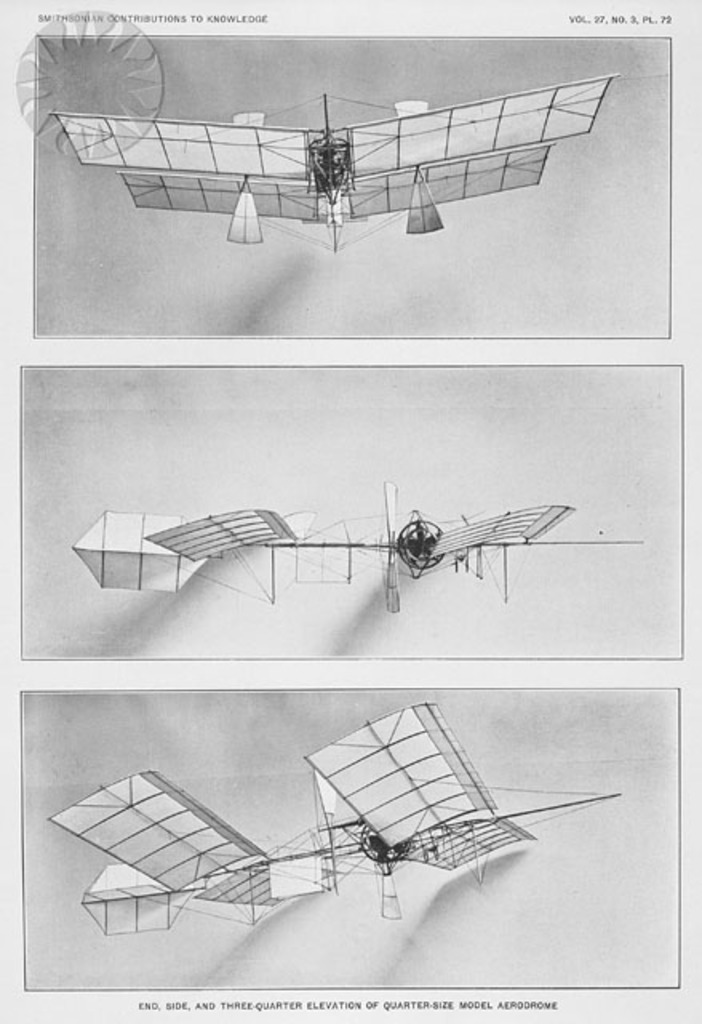How does the design of the airplane model reflect the aerodynamic principles of the early 20th century? The design reflects early 20th-century attempts to enhance lift and aerodynamic efficiency through its biplane configuration, which increased wing area without a proportionate increase in wingspan. Also, the use of lightweight materials and specific wing angles were strategies to improve the balance between lift and drag, crucial for the rudimentary engines of that era. 